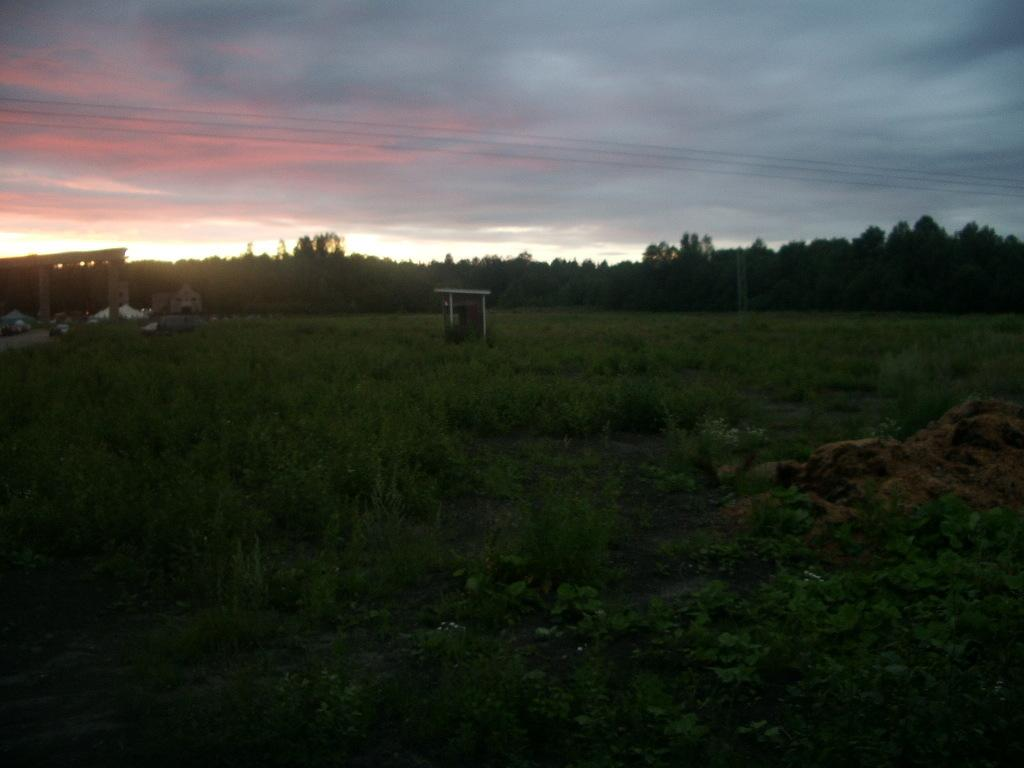What type of vegetation is present at the bottom of the image? There is grass and plants at the bottom of the image. What can be seen in the background of the image? There are trees in the background of the image. What is visible at the top of the image? The sky is visible at the top of the image. What type of jar is used to cover the trees in the image? There is no jar present in the image, and the trees are not covered. What trick is being performed with the grass and plants at the bottom of the image? There is no trick being performed in the image; the grass and plants are simply present. 